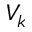<formula> <loc_0><loc_0><loc_500><loc_500>V _ { k }</formula> 